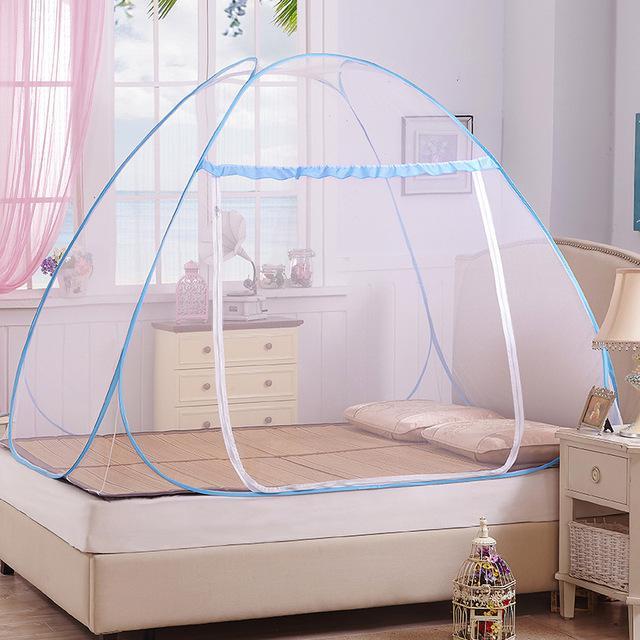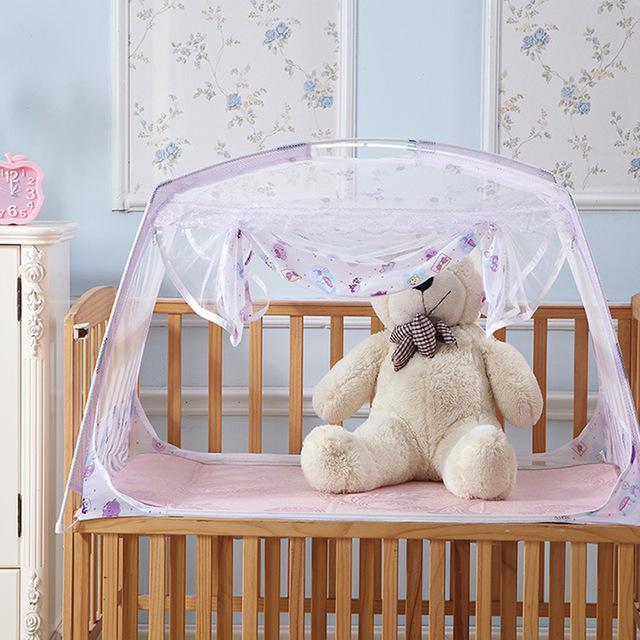The first image is the image on the left, the second image is the image on the right. Assess this claim about the two images: "A tented net covers a sleeping area with a stuffed animal in the image on the right.". Correct or not? Answer yes or no. Yes. The first image is the image on the left, the second image is the image on the right. For the images shown, is this caption "There are two canopies and at least one is a tent." true? Answer yes or no. Yes. 